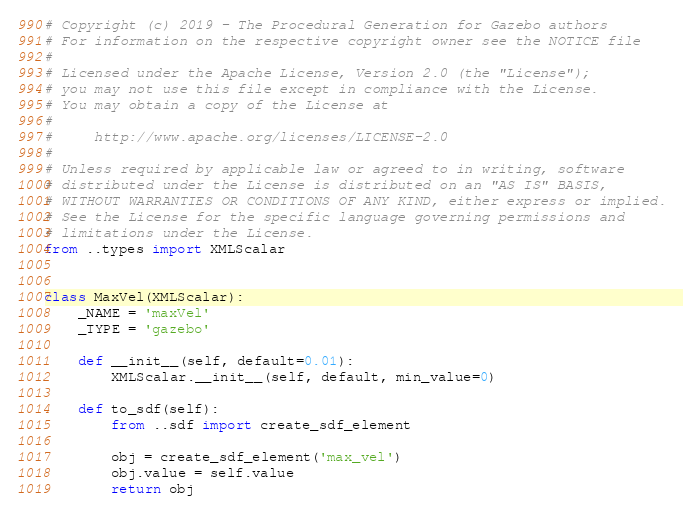Convert code to text. <code><loc_0><loc_0><loc_500><loc_500><_Python_># Copyright (c) 2019 - The Procedural Generation for Gazebo authors
# For information on the respective copyright owner see the NOTICE file
#
# Licensed under the Apache License, Version 2.0 (the "License");
# you may not use this file except in compliance with the License.
# You may obtain a copy of the License at
#
#     http://www.apache.org/licenses/LICENSE-2.0
#
# Unless required by applicable law or agreed to in writing, software
# distributed under the License is distributed on an "AS IS" BASIS,
# WITHOUT WARRANTIES OR CONDITIONS OF ANY KIND, either express or implied.
# See the License for the specific language governing permissions and
# limitations under the License.
from ..types import XMLScalar


class MaxVel(XMLScalar):
    _NAME = 'maxVel'
    _TYPE = 'gazebo'

    def __init__(self, default=0.01):
        XMLScalar.__init__(self, default, min_value=0)

    def to_sdf(self):
        from ..sdf import create_sdf_element

        obj = create_sdf_element('max_vel')
        obj.value = self.value
        return obj
</code> 